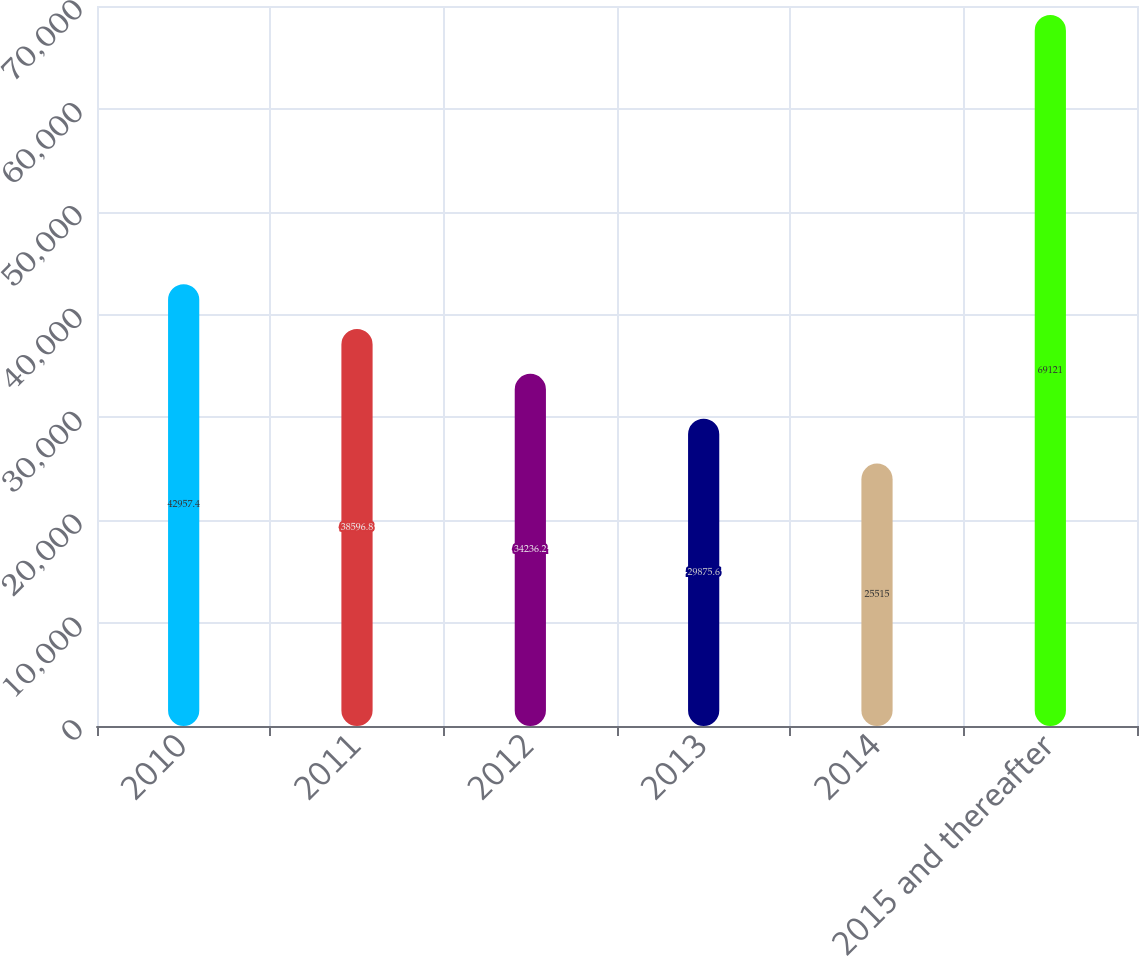<chart> <loc_0><loc_0><loc_500><loc_500><bar_chart><fcel>2010<fcel>2011<fcel>2012<fcel>2013<fcel>2014<fcel>2015 and thereafter<nl><fcel>42957.4<fcel>38596.8<fcel>34236.2<fcel>29875.6<fcel>25515<fcel>69121<nl></chart> 